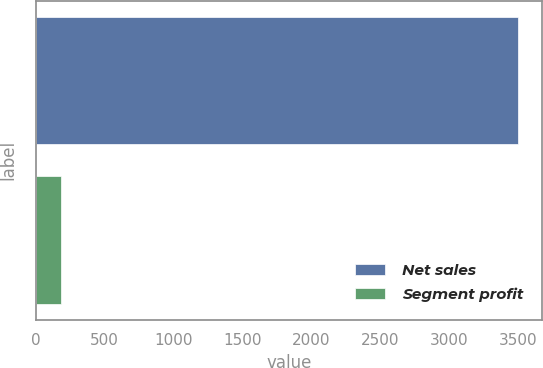<chart> <loc_0><loc_0><loc_500><loc_500><bar_chart><fcel>Net sales<fcel>Segment profit<nl><fcel>3497<fcel>184<nl></chart> 